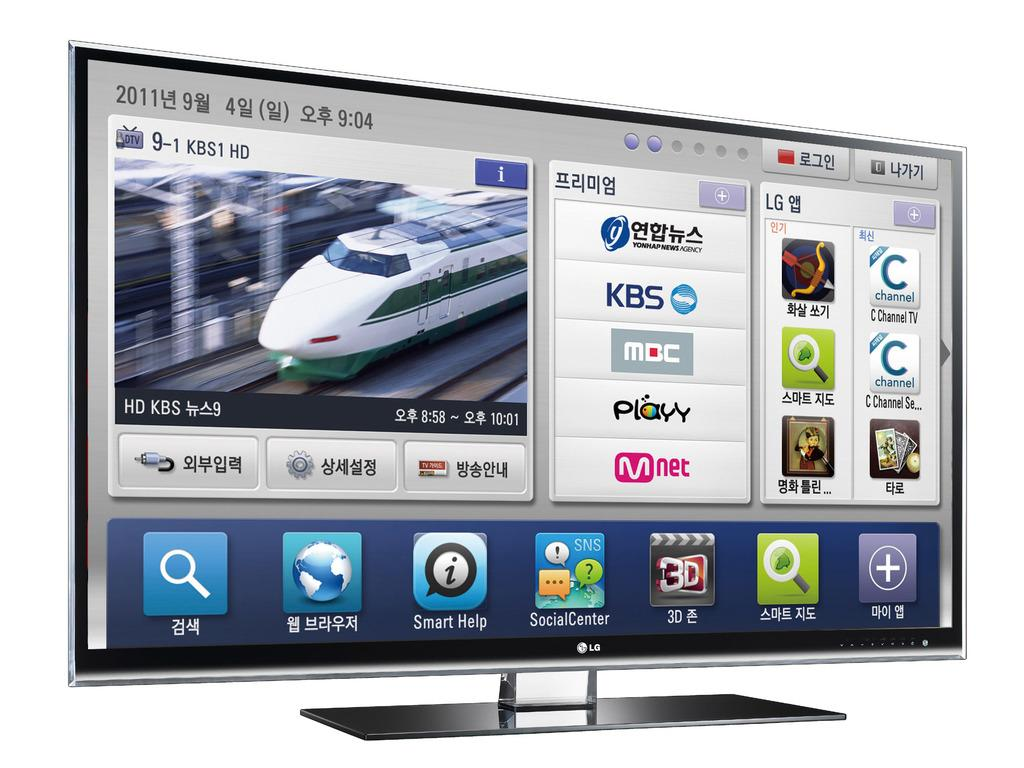<image>
Give a short and clear explanation of the subsequent image. A very big LG smart television with a white background behind it. 